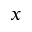Convert formula to latex. <formula><loc_0><loc_0><loc_500><loc_500>x</formula> 